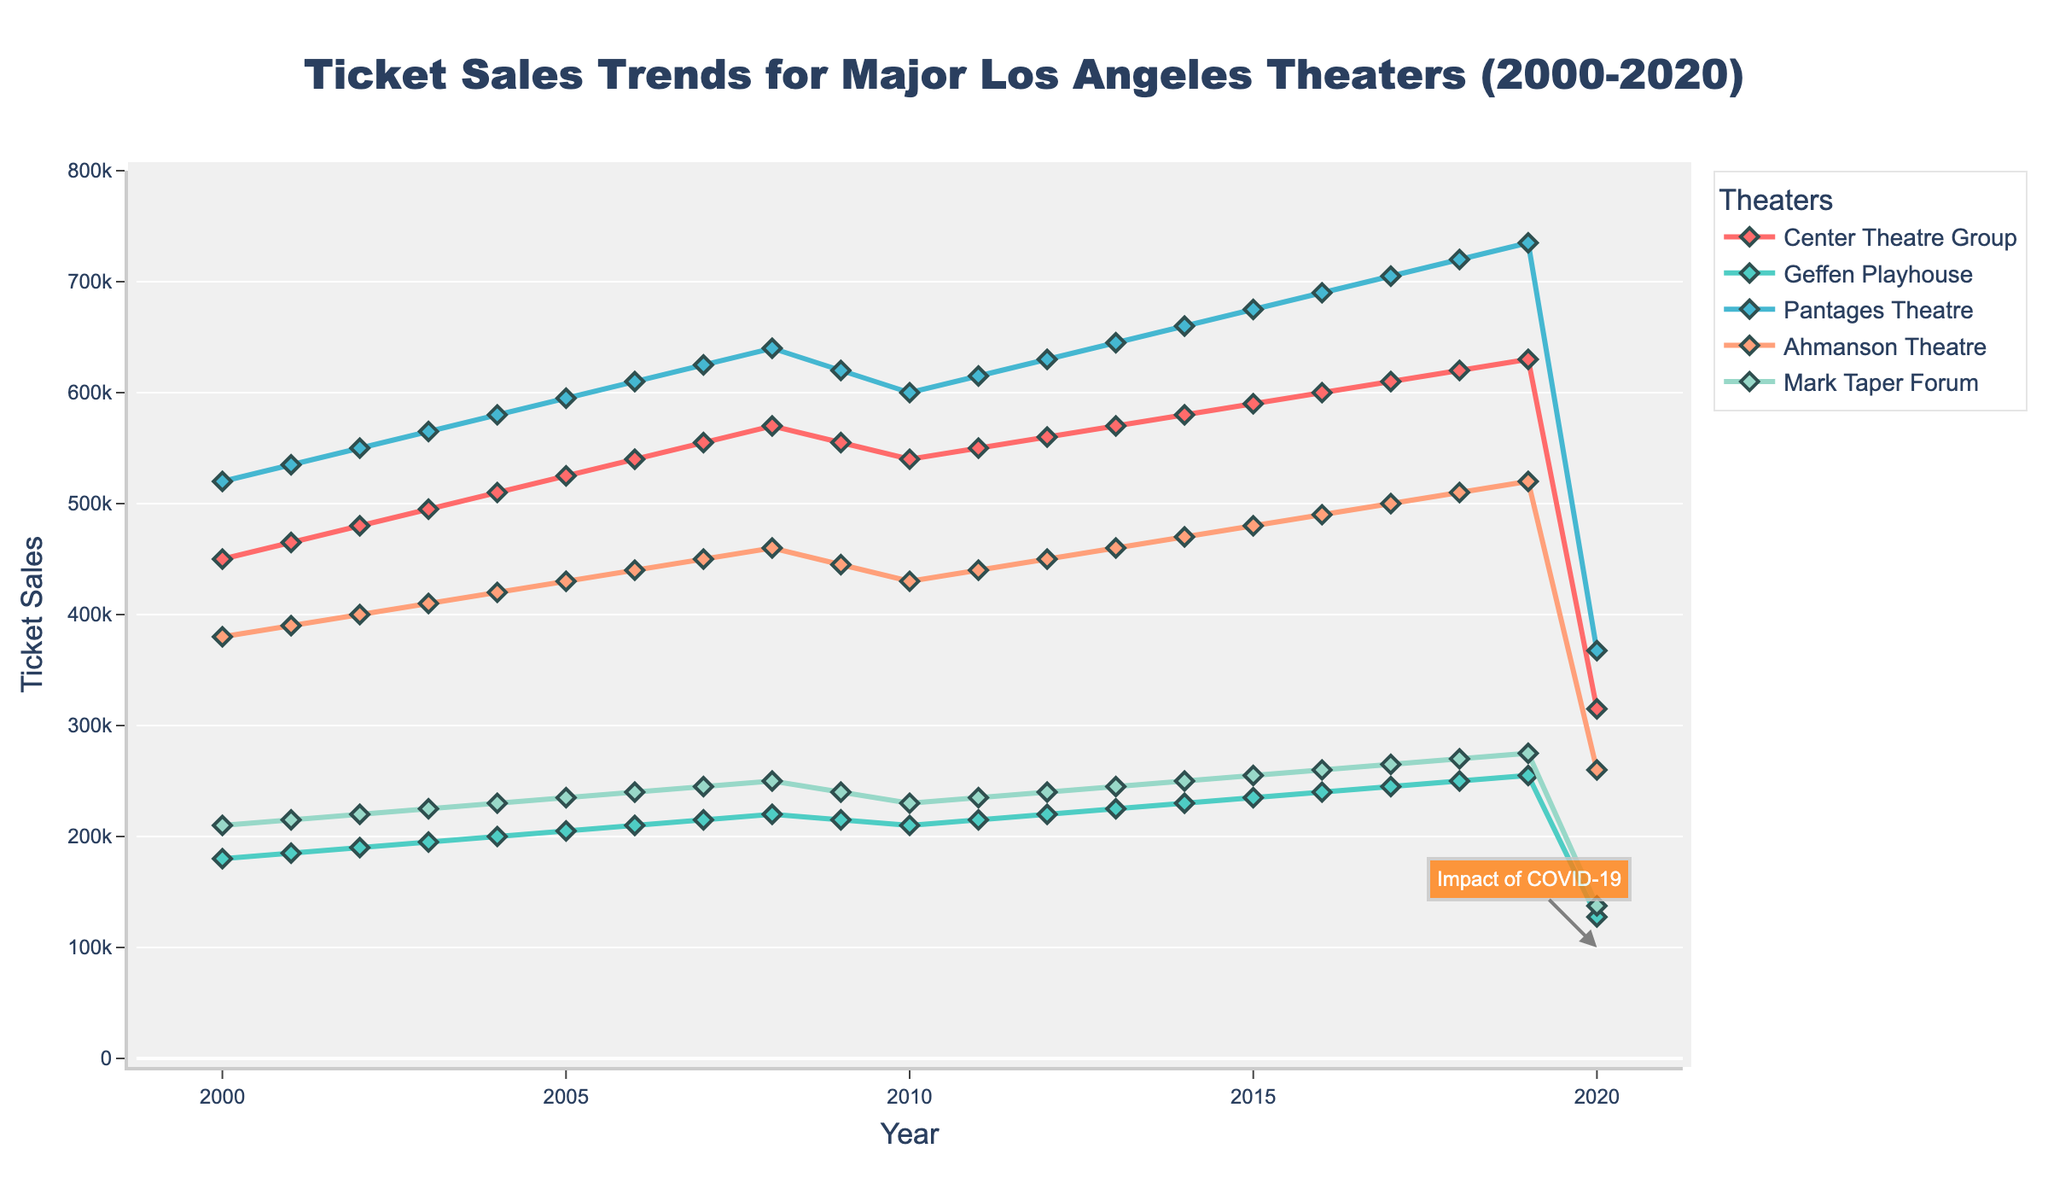What's the average ticket sales of the Center Theatre Group from 2000 to 2019? Add up the values from 2000 to 2019 for the Center Theatre Group, which are: 450000, 465000, 480000, 495000, 510000, 525000, 540000, 555000, 570000, 555000, 540000, 550000, 560000, 570000, 580000, 590000, 600000, 610000, 620000, 630000. The sum is 10620000. Divide this sum by 20 to find the average. 10620000 / 20 = 531000.
Answer: 531000 How did ticket sales for the Pantages Theatre change from 2000 to 2020? In 2000, the ticket sales for the Pantages Theatre were 520000. By 2020, they decreased to 367500. This difference can be calculated as 520000 - 367500 = 152500.
Answer: Decreased by 152500 Which theater experienced the highest ticket sales in 2010? Examine the ticket sales for each theater in 2010: Center Theatre Group (540000), Geffen Playhouse (210000), Pantages Theatre (600000), Ahmanson Theatre (430000), Mark Taper Forum (230000). The highest value is 600000 for the Pantages Theatre.
Answer: Pantages Theatre What visual evidence suggests an impact of COVID-19 on ticket sales in 2020? The figure includes a significant drop in ticket sales for all theaters in 2020 along with an annotation indicating the "Impact of COVID-19." Sales drop to their lowest points across the 20-year period.
Answer: Drop in sales annotation Compare the ticket sales trends of the Ahmanson Theatre and the Mark Taper Forum from 2000 to 2020. Both theaters show a general increasing trend from 2000 to 2019. In 2020, both theaters experienced a significant drop due to COVID-19. The Ahmanson Theatre generally had higher ticket sales than the Mark Taper Forum throughout the period.
Answer: Ahmanson Theatre generally higher, COVID-19 drop What is the total decrease in ticket sales for the Geffen Playhouse from 2019 to 2020? In 2019, the ticket sales for the Geffen Playhouse were 255000. In 2020, they decreased to 127500. The difference is 255000 - 127500 = 127500.
Answer: 127500 How do the ticket sales trends of the Center Theatre Group and the Pantages Theatre compare from 2000 to 2020? Both theaters experienced growth from 2000 to 2019, but the Pantages Theatre maintained higher sales than the Center Theatre Group throughout this period. In 2020, both theaters saw a significant drop; Center Theatre Group dropped to 315000 and Pantages Theatre to 367500.
Answer: Pantages Theatre higher, both dropped in 2020 What was the peak ticket sales value for the Mark Taper Forum, and in which year did it occur? The highest ticket sales for the Mark Taper Forum occurred in 2019 with a value of 275000.
Answer: 275000 in 2019 By how much did the ticket sales of the Ahmanson Theatre increase from 2000 to 2019? In 2000, the ticket sales were 380000 and in 2019 they were 520000. The increase is 520000 - 380000 = 140000.
Answer: 140000 